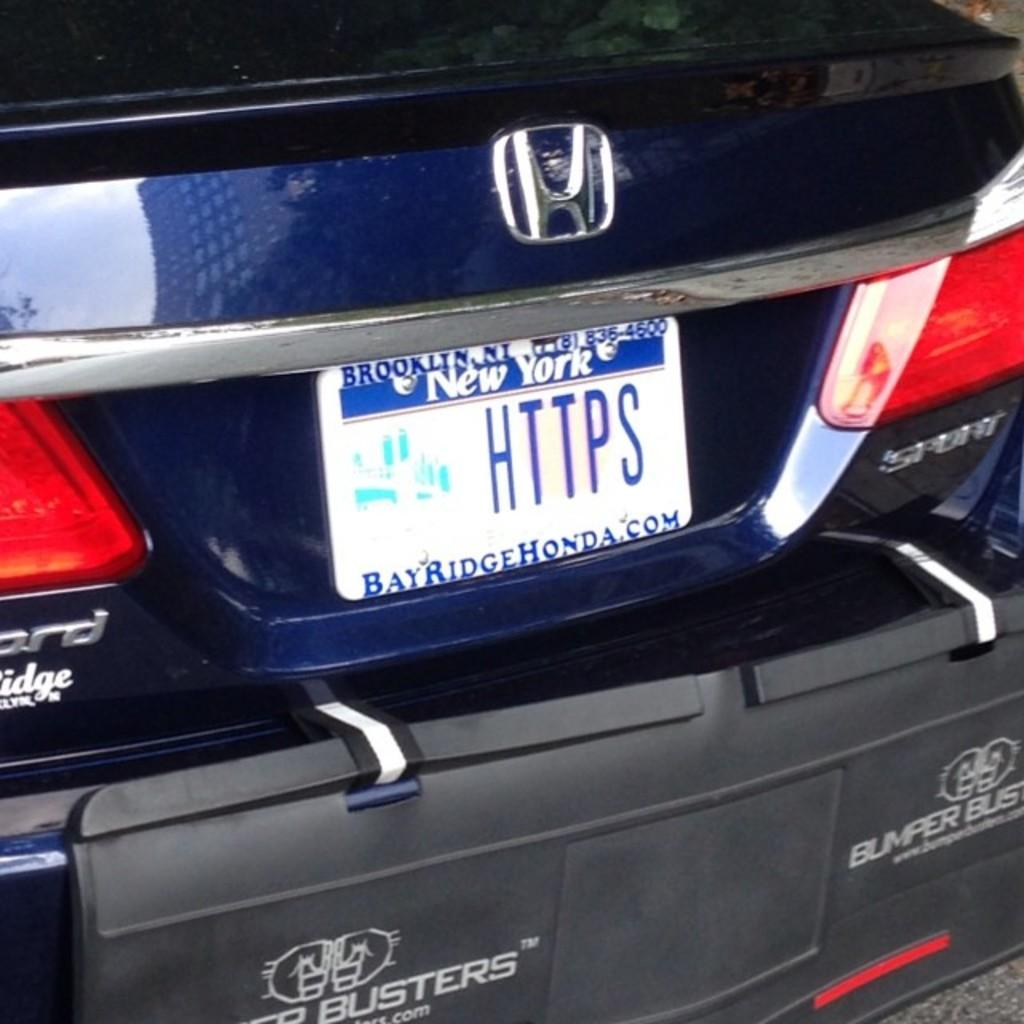<image>
Share a concise interpretation of the image provided. A license plate on a car shows the letters HTTPS 